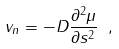<formula> <loc_0><loc_0><loc_500><loc_500>v _ { n } = - D \frac { \partial ^ { 2 } \mu } { \partial s ^ { 2 } } \ ,</formula> 